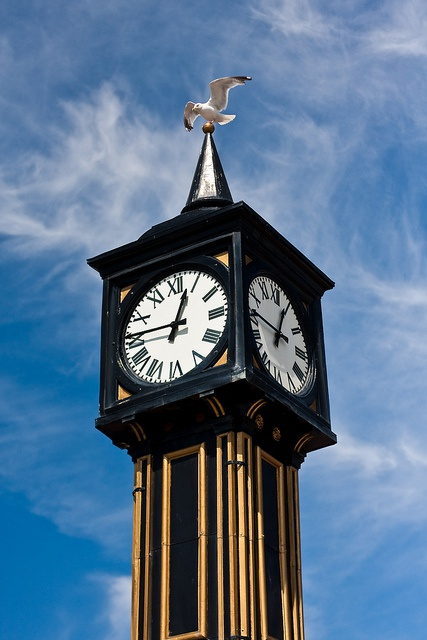Describe the objects in this image and their specific colors. I can see clock in gray, white, black, and darkgray tones, clock in gray, darkgray, black, and lightgray tones, and bird in gray, darkgray, and lightgray tones in this image. 